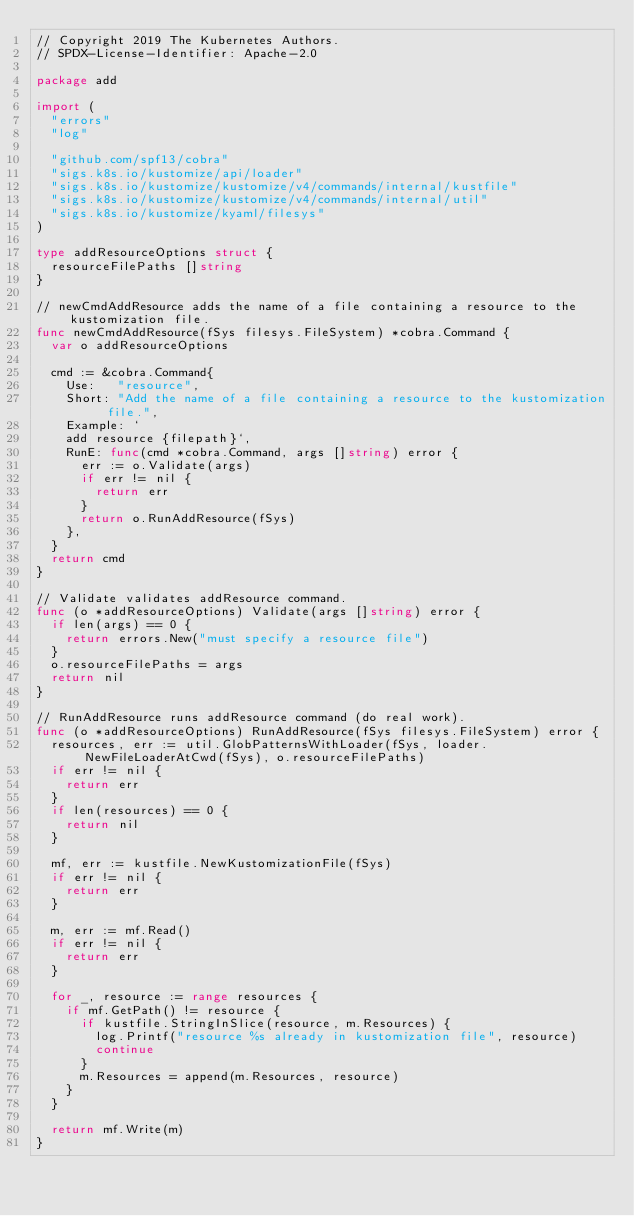Convert code to text. <code><loc_0><loc_0><loc_500><loc_500><_Go_>// Copyright 2019 The Kubernetes Authors.
// SPDX-License-Identifier: Apache-2.0

package add

import (
	"errors"
	"log"

	"github.com/spf13/cobra"
	"sigs.k8s.io/kustomize/api/loader"
	"sigs.k8s.io/kustomize/kustomize/v4/commands/internal/kustfile"
	"sigs.k8s.io/kustomize/kustomize/v4/commands/internal/util"
	"sigs.k8s.io/kustomize/kyaml/filesys"
)

type addResourceOptions struct {
	resourceFilePaths []string
}

// newCmdAddResource adds the name of a file containing a resource to the kustomization file.
func newCmdAddResource(fSys filesys.FileSystem) *cobra.Command {
	var o addResourceOptions

	cmd := &cobra.Command{
		Use:   "resource",
		Short: "Add the name of a file containing a resource to the kustomization file.",
		Example: `
		add resource {filepath}`,
		RunE: func(cmd *cobra.Command, args []string) error {
			err := o.Validate(args)
			if err != nil {
				return err
			}
			return o.RunAddResource(fSys)
		},
	}
	return cmd
}

// Validate validates addResource command.
func (o *addResourceOptions) Validate(args []string) error {
	if len(args) == 0 {
		return errors.New("must specify a resource file")
	}
	o.resourceFilePaths = args
	return nil
}

// RunAddResource runs addResource command (do real work).
func (o *addResourceOptions) RunAddResource(fSys filesys.FileSystem) error {
	resources, err := util.GlobPatternsWithLoader(fSys, loader.NewFileLoaderAtCwd(fSys), o.resourceFilePaths)
	if err != nil {
		return err
	}
	if len(resources) == 0 {
		return nil
	}

	mf, err := kustfile.NewKustomizationFile(fSys)
	if err != nil {
		return err
	}

	m, err := mf.Read()
	if err != nil {
		return err
	}

	for _, resource := range resources {
		if mf.GetPath() != resource {
			if kustfile.StringInSlice(resource, m.Resources) {
				log.Printf("resource %s already in kustomization file", resource)
				continue
			}
			m.Resources = append(m.Resources, resource)
		}
	}

	return mf.Write(m)
}
</code> 